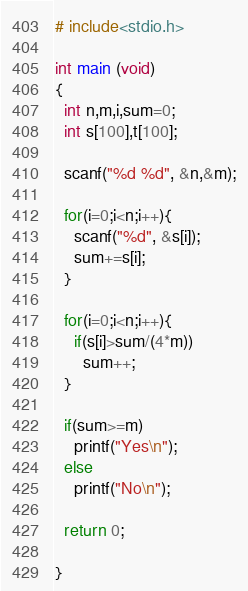<code> <loc_0><loc_0><loc_500><loc_500><_C_># include<stdio.h>

int main (void)
{
  int n,m,i,sum=0;
  int s[100],t[100];
  
  scanf("%d %d", &n,&m);
  
  for(i=0;i<n;i++){
    scanf("%d", &s[i]);
    sum+=s[i];
  }
  
  for(i=0;i<n;i++){
    if(s[i]>sum/(4*m))
      sum++;
  }
  
  if(sum>=m)
    printf("Yes\n");
  else
    printf("No\n");
  
  return 0;
  
}</code> 